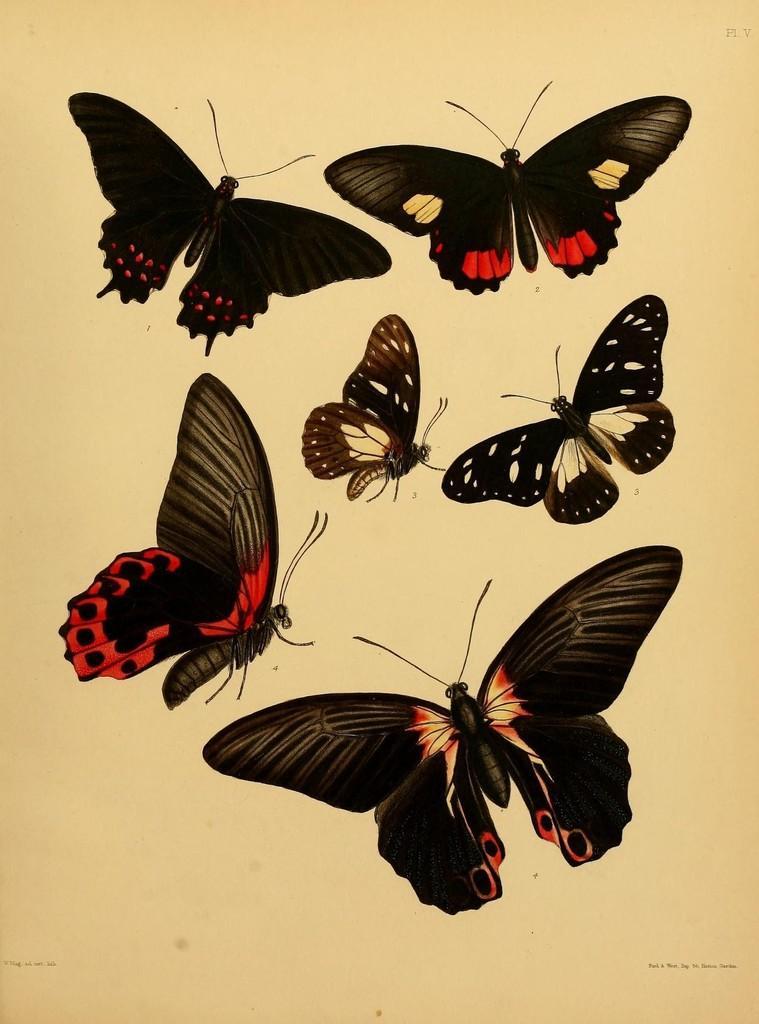Can you describe this image briefly? This image consists of a paper with a few images of butterflies on it. 